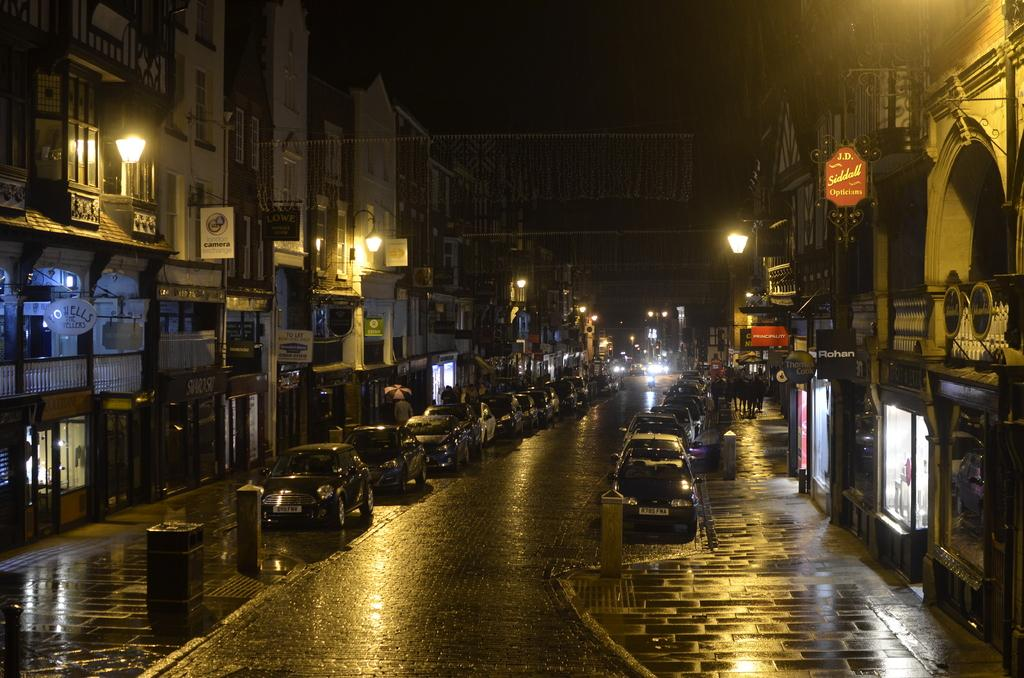What type of structures can be seen in the image? There are buildings in the image. What objects are present in the image? There are boards, vehicles, people, an umbrella, lights, a railing, stores, and objects in the image. Can you describe the vehicles in the image? Vehicles are in the image, and some of them are on the walkway. What is the condition of the sky in the image? The sky is dark in the image. What might be the purpose of the railing in the image? The railing in the image might be for safety or to prevent people from falling. What type of goldfish can be seen swimming in the image? There are no goldfish present in the image. What type of lunch is being served in the image? There is no lunch being served in the image. 